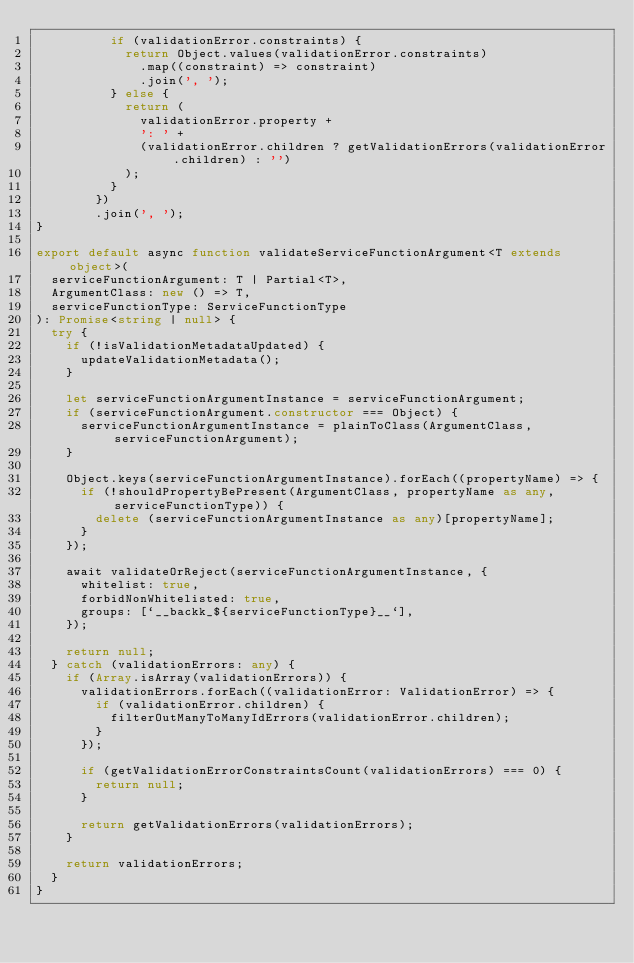Convert code to text. <code><loc_0><loc_0><loc_500><loc_500><_TypeScript_>          if (validationError.constraints) {
            return Object.values(validationError.constraints)
              .map((constraint) => constraint)
              .join(', ');
          } else {
            return (
              validationError.property +
              ': ' +
              (validationError.children ? getValidationErrors(validationError.children) : '')
            );
          }
        })
        .join(', ');
}

export default async function validateServiceFunctionArgument<T extends object>(
  serviceFunctionArgument: T | Partial<T>,
  ArgumentClass: new () => T,
  serviceFunctionType: ServiceFunctionType
): Promise<string | null> {
  try {
    if (!isValidationMetadataUpdated) {
      updateValidationMetadata();
    }

    let serviceFunctionArgumentInstance = serviceFunctionArgument;
    if (serviceFunctionArgument.constructor === Object) {
      serviceFunctionArgumentInstance = plainToClass(ArgumentClass, serviceFunctionArgument);
    }

    Object.keys(serviceFunctionArgumentInstance).forEach((propertyName) => {
      if (!shouldPropertyBePresent(ArgumentClass, propertyName as any, serviceFunctionType)) {
        delete (serviceFunctionArgumentInstance as any)[propertyName];
      }
    });

    await validateOrReject(serviceFunctionArgumentInstance, {
      whitelist: true,
      forbidNonWhitelisted: true,
      groups: [`__backk_${serviceFunctionType}__`],
    });

    return null;
  } catch (validationErrors: any) {
    if (Array.isArray(validationErrors)) {
      validationErrors.forEach((validationError: ValidationError) => {
        if (validationError.children) {
          filterOutManyToManyIdErrors(validationError.children);
        }
      });

      if (getValidationErrorConstraintsCount(validationErrors) === 0) {
        return null;
      }

      return getValidationErrors(validationErrors);
    }

    return validationErrors;
  }
}
</code> 